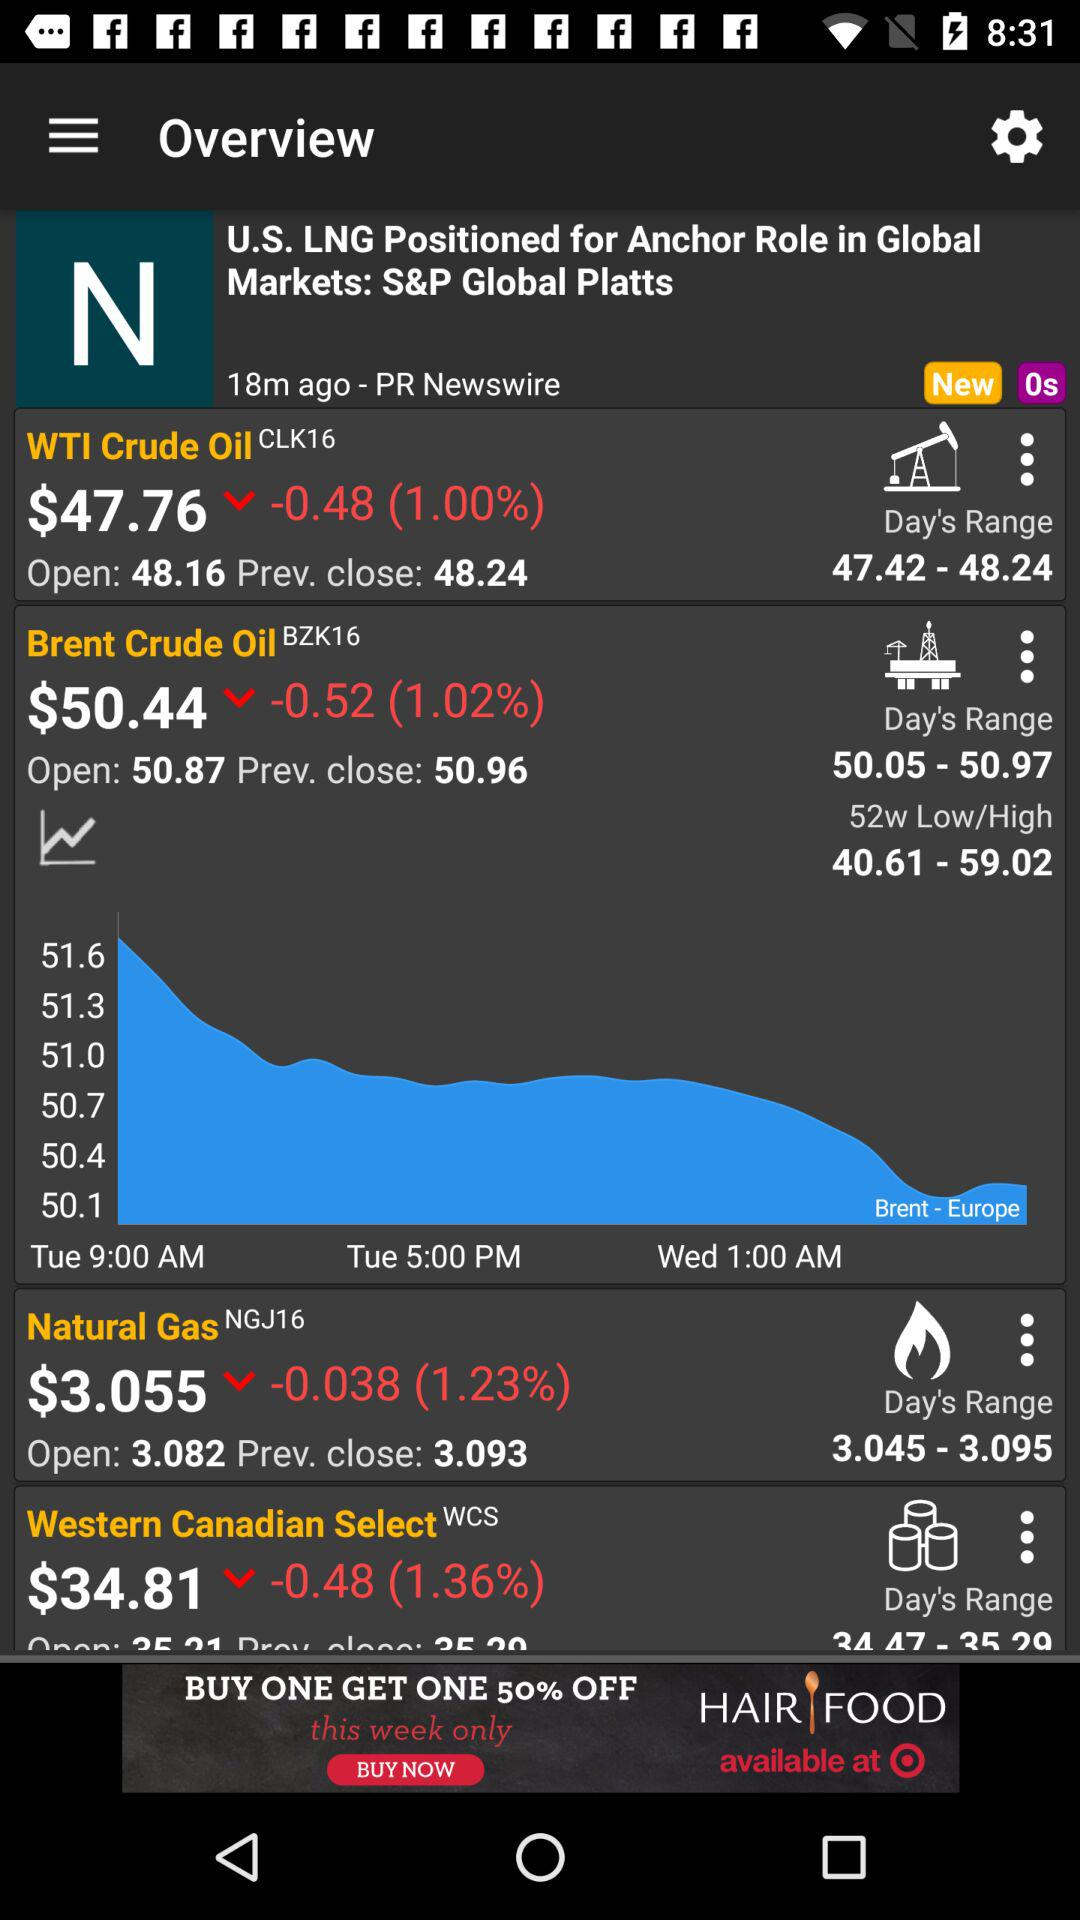What is the "Day's Range" of "Western Canadian Select"? The "Day's Range" of "Western Canadian Select" is from 34.47 to 35.29. 